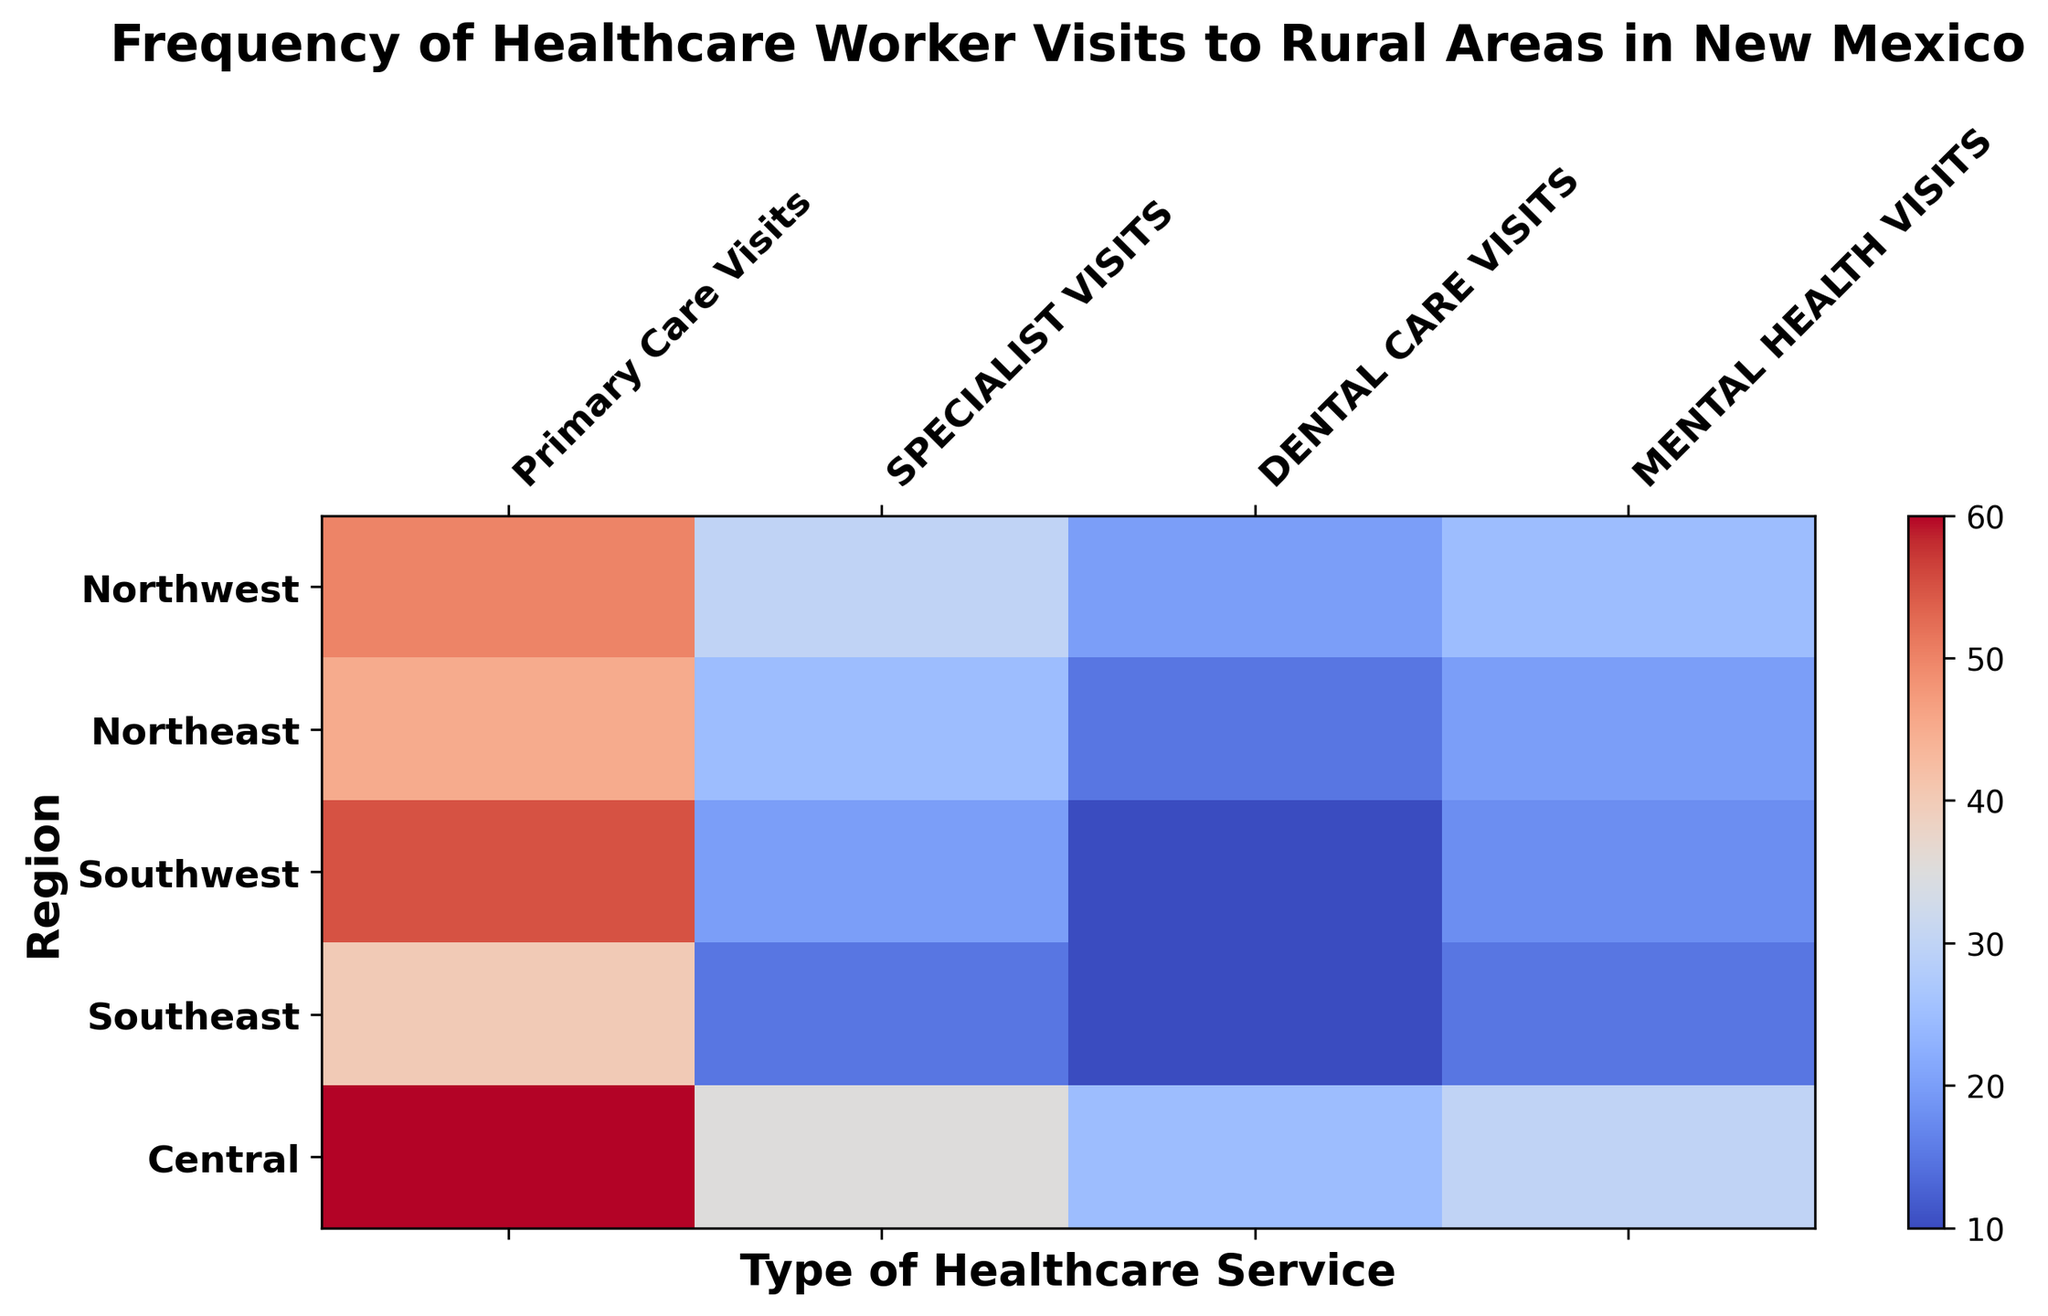Which region has the highest frequency of Primary Care Visits? The figure visually shows the frequency of healthcare worker visits for different services in various regions. For Primary Care Visits, the region with the darkest red color indicates the highest frequency. In this case, Central has the darkest red shade under Primary Care Visits.
Answer: Central Which type of healthcare service has the lowest frequency of visits in the Northeast region? By examining the Northeast row in the heatmap, the lightest color indicates the lowest frequency. Dental Care Visits have the lightest shade in this row.
Answer: Dental Care Visits What is the total frequency of Mental Health Visits across all regions? Sum the values of Mental Health Visits from all regions: 25 (Northwest) + 20 (Northeast) + 18 (Southwest) + 15 (Southeast) + 30 (Central). The total is 25 + 20 + 18 + 15 + 30 = 108.
Answer: 108 Which region has the least frequency of Specialist Visits, and how many visits were recorded? Check each row for the column Specialist Visits and identify the lightest color, which indicates the least frequency. The Southeast region has the lightest color with 15 visits.
Answer: Southeast, 15 Compare the frequency of Dental Care Visits in Central and Southwest regions. Which region has more visits and by how much? Find the values for Dental Care Visits in both regions. Central has 25 visits, and Southwest has 10 visits. The difference is 25 - 10 = 15, so Central has 15 more visits.
Answer: Central, 15 Which region has the most even distribution of healthcare worker visits across all types of services? To determine the most even distribution, look for the region with the least variation in shades across the row. The Central region has relatively similar shades for all types of healthcare services, indicating an even distribution.
Answer: Central What is the average number of Primary Care Visits across all regions? Sum the values of Primary Care Visits from all regions and divide by the number of regions: (50 + 45 + 55 + 40 + 60) / 5 = 250 / 5. The average is 50.
Answer: 50 Which type of healthcare service shows the greatest variability in frequency across the regions? By examining the columns, the color shades in Specialist Visits show significant variation from dark red (high frequency) in Central to light pink (low frequency) in Southeast.
Answer: Specialist Visits 